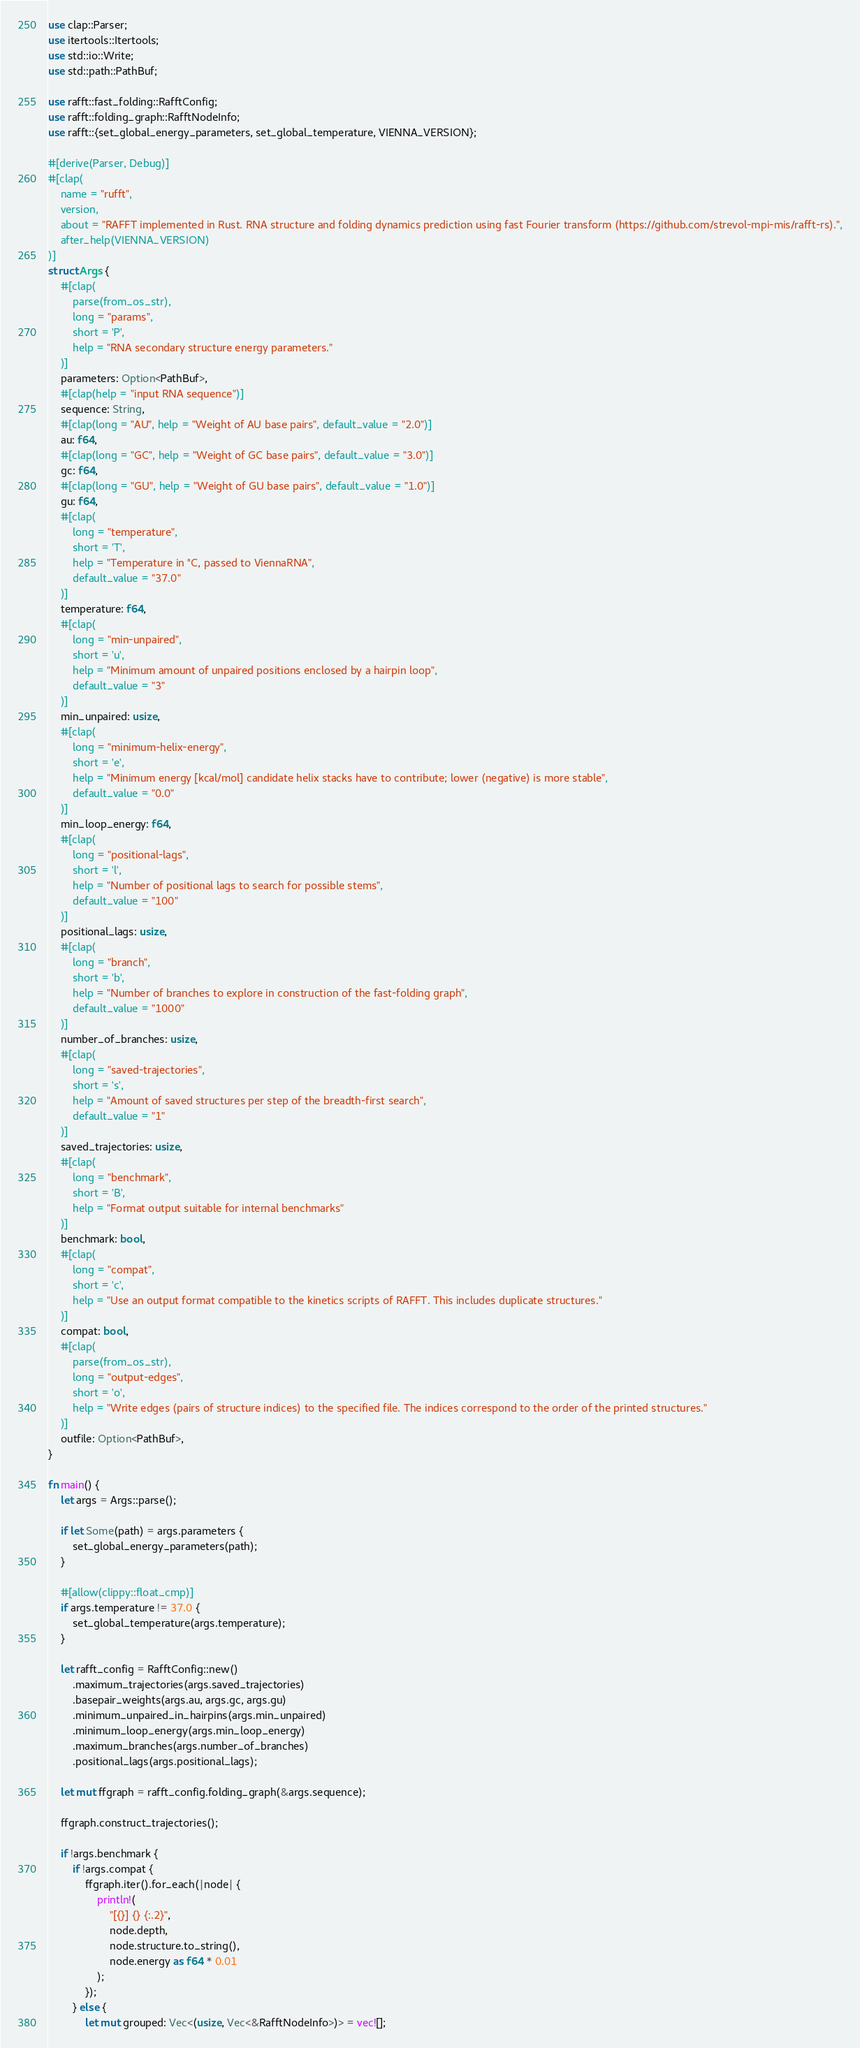Convert code to text. <code><loc_0><loc_0><loc_500><loc_500><_Rust_>use clap::Parser;
use itertools::Itertools;
use std::io::Write;
use std::path::PathBuf;

use rafft::fast_folding::RafftConfig;
use rafft::folding_graph::RafftNodeInfo;
use rafft::{set_global_energy_parameters, set_global_temperature, VIENNA_VERSION};

#[derive(Parser, Debug)]
#[clap(
    name = "rufft",
    version,
    about = "RAFFT implemented in Rust. RNA structure and folding dynamics prediction using fast Fourier transform (https://github.com/strevol-mpi-mis/rafft-rs).",
    after_help(VIENNA_VERSION)
)]
struct Args {
    #[clap(
        parse(from_os_str),
        long = "params",
        short = 'P',
        help = "RNA secondary structure energy parameters."
    )]
    parameters: Option<PathBuf>,
    #[clap(help = "input RNA sequence")]
    sequence: String,
    #[clap(long = "AU", help = "Weight of AU base pairs", default_value = "2.0")]
    au: f64,
    #[clap(long = "GC", help = "Weight of GC base pairs", default_value = "3.0")]
    gc: f64,
    #[clap(long = "GU", help = "Weight of GU base pairs", default_value = "1.0")]
    gu: f64,
    #[clap(
        long = "temperature",
        short = 'T',
        help = "Temperature in °C, passed to ViennaRNA",
        default_value = "37.0"
    )]
    temperature: f64,
    #[clap(
        long = "min-unpaired",
        short = 'u',
        help = "Minimum amount of unpaired positions enclosed by a hairpin loop",
        default_value = "3"
    )]
    min_unpaired: usize,
    #[clap(
        long = "minimum-helix-energy",
        short = 'e',
        help = "Minimum energy [kcal/mol] candidate helix stacks have to contribute; lower (negative) is more stable",
        default_value = "0.0"
    )]
    min_loop_energy: f64,
    #[clap(
        long = "positional-lags",
        short = 'l',
        help = "Number of positional lags to search for possible stems",
        default_value = "100"
    )]
    positional_lags: usize,
    #[clap(
        long = "branch",
        short = 'b',
        help = "Number of branches to explore in construction of the fast-folding graph",
        default_value = "1000"
    )]
    number_of_branches: usize,
    #[clap(
        long = "saved-trajectories",
        short = 's',
        help = "Amount of saved structures per step of the breadth-first search",
        default_value = "1"
    )]
    saved_trajectories: usize,
    #[clap(
        long = "benchmark",
        short = 'B',
        help = "Format output suitable for internal benchmarks"
    )]
    benchmark: bool,
    #[clap(
        long = "compat",
        short = 'c',
        help = "Use an output format compatible to the kinetics scripts of RAFFT. This includes duplicate structures."
    )]
    compat: bool,
    #[clap(
        parse(from_os_str),
        long = "output-edges",
        short = 'o',
        help = "Write edges (pairs of structure indices) to the specified file. The indices correspond to the order of the printed structures."
    )]
    outfile: Option<PathBuf>,
}

fn main() {
    let args = Args::parse();

    if let Some(path) = args.parameters {
        set_global_energy_parameters(path);
    }

    #[allow(clippy::float_cmp)]
    if args.temperature != 37.0 {
        set_global_temperature(args.temperature);
    }

    let rafft_config = RafftConfig::new()
        .maximum_trajectories(args.saved_trajectories)
        .basepair_weights(args.au, args.gc, args.gu)
        .minimum_unpaired_in_hairpins(args.min_unpaired)
        .minimum_loop_energy(args.min_loop_energy)
        .maximum_branches(args.number_of_branches)
        .positional_lags(args.positional_lags);

    let mut ffgraph = rafft_config.folding_graph(&args.sequence);

    ffgraph.construct_trajectories();

    if !args.benchmark {
        if !args.compat {
            ffgraph.iter().for_each(|node| {
                println!(
                    "[{}] {} {:.2}",
                    node.depth,
                    node.structure.to_string(),
                    node.energy as f64 * 0.01
                );
            });
        } else {
            let mut grouped: Vec<(usize, Vec<&RafftNodeInfo>)> = vec![];</code> 